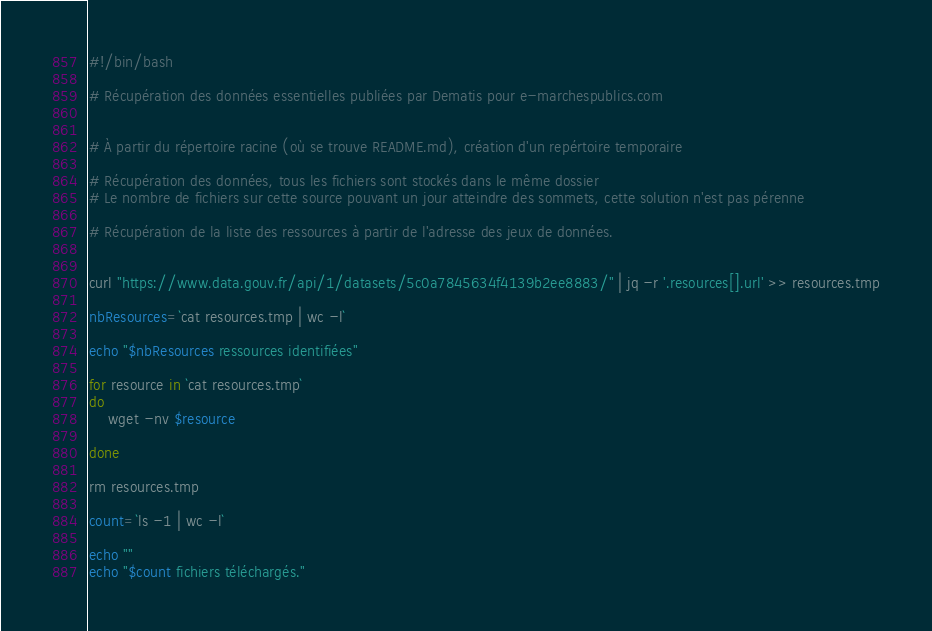Convert code to text. <code><loc_0><loc_0><loc_500><loc_500><_Bash_>#!/bin/bash

# Récupération des données essentielles publiées par Dematis pour e-marchespublics.com


# À partir du répertoire racine (où se trouve README.md), création d'un repértoire temporaire

# Récupération des données, tous les fichiers sont stockés dans le même dossier
# Le nombre de fichiers sur cette source pouvant un jour atteindre des sommets, cette solution n'est pas pérenne

# Récupération de la liste des ressources à partir de l'adresse des jeux de données.


curl "https://www.data.gouv.fr/api/1/datasets/5c0a7845634f4139b2ee8883/" | jq -r '.resources[].url' >> resources.tmp

nbResources=`cat resources.tmp | wc -l`

echo "$nbResources ressources identifiées"

for resource in `cat resources.tmp`
do
    wget -nv $resource

done

rm resources.tmp

count=`ls -1 | wc -l`

echo ""
echo "$count fichiers téléchargés."
</code> 